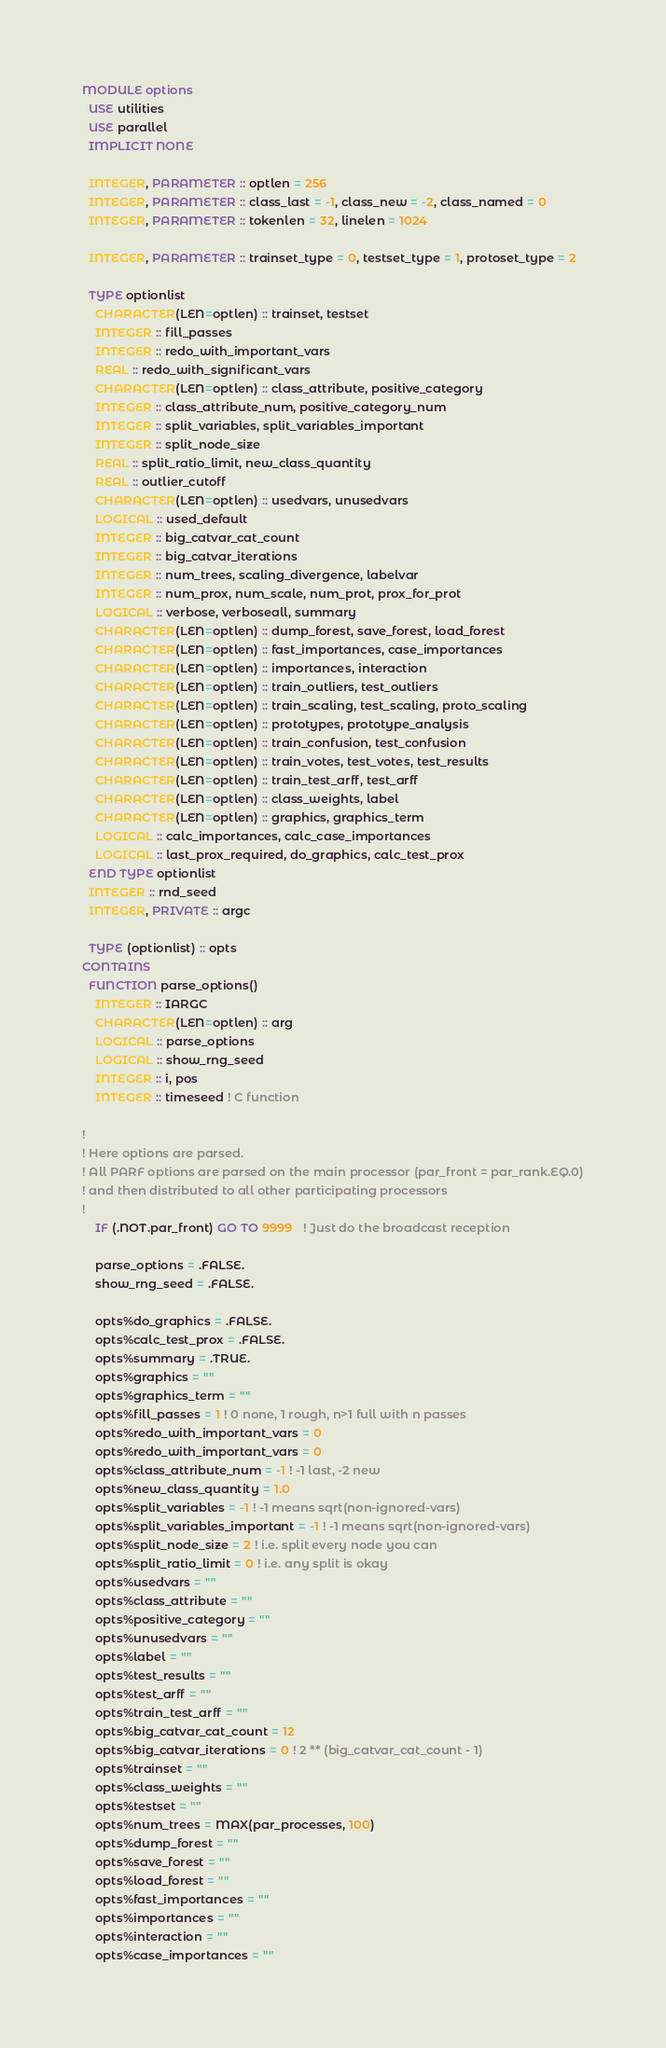<code> <loc_0><loc_0><loc_500><loc_500><_FORTRAN_>MODULE options
  USE utilities
  USE parallel
  IMPLICIT NONE

  INTEGER, PARAMETER :: optlen = 256
  INTEGER, PARAMETER :: class_last = -1, class_new = -2, class_named = 0
  INTEGER, PARAMETER :: tokenlen = 32, linelen = 1024

  INTEGER, PARAMETER :: trainset_type = 0, testset_type = 1, protoset_type = 2

  TYPE optionlist
    CHARACTER(LEN=optlen) :: trainset, testset
    INTEGER :: fill_passes
    INTEGER :: redo_with_important_vars
    REAL :: redo_with_significant_vars
    CHARACTER(LEN=optlen) :: class_attribute, positive_category
    INTEGER :: class_attribute_num, positive_category_num
    INTEGER :: split_variables, split_variables_important
    INTEGER :: split_node_size
    REAL :: split_ratio_limit, new_class_quantity
    REAL :: outlier_cutoff
    CHARACTER(LEN=optlen) :: usedvars, unusedvars
    LOGICAL :: used_default
    INTEGER :: big_catvar_cat_count
    INTEGER :: big_catvar_iterations 
    INTEGER :: num_trees, scaling_divergence, labelvar
    INTEGER :: num_prox, num_scale, num_prot, prox_for_prot
    LOGICAL :: verbose, verboseall, summary
    CHARACTER(LEN=optlen) :: dump_forest, save_forest, load_forest
    CHARACTER(LEN=optlen) :: fast_importances, case_importances
    CHARACTER(LEN=optlen) :: importances, interaction
    CHARACTER(LEN=optlen) :: train_outliers, test_outliers
    CHARACTER(LEN=optlen) :: train_scaling, test_scaling, proto_scaling
    CHARACTER(LEN=optlen) :: prototypes, prototype_analysis
    CHARACTER(LEN=optlen) :: train_confusion, test_confusion
    CHARACTER(LEN=optlen) :: train_votes, test_votes, test_results
    CHARACTER(LEN=optlen) :: train_test_arff, test_arff
    CHARACTER(LEN=optlen) :: class_weights, label
    CHARACTER(LEN=optlen) :: graphics, graphics_term
    LOGICAL :: calc_importances, calc_case_importances
    LOGICAL :: last_prox_required, do_graphics, calc_test_prox
  END TYPE optionlist
  INTEGER :: rnd_seed
  INTEGER, PRIVATE :: argc

  TYPE (optionlist) :: opts
CONTAINS
  FUNCTION parse_options()
    INTEGER :: IARGC
    CHARACTER(LEN=optlen) :: arg
    LOGICAL :: parse_options
    LOGICAL :: show_rng_seed
    INTEGER :: i, pos
    INTEGER :: timeseed ! C function

!
! Here options are parsed.
! All PARF options are parsed on the main processor (par_front = par_rank.EQ.0)
! and then distributed to all other participating processors
! 
    IF (.NOT.par_front) GO TO 9999   ! Just do the broadcast reception

    parse_options = .FALSE.
    show_rng_seed = .FALSE.

    opts%do_graphics = .FALSE.
    opts%calc_test_prox = .FALSE.
    opts%summary = .TRUE.
    opts%graphics = ""
    opts%graphics_term = ""
    opts%fill_passes = 1 ! 0 none, 1 rough, n>1 full with n passes
    opts%redo_with_important_vars = 0
    opts%redo_with_important_vars = 0
    opts%class_attribute_num = -1 ! -1 last, -2 new
    opts%new_class_quantity = 1.0
    opts%split_variables = -1 ! -1 means sqrt(non-ignored-vars)
    opts%split_variables_important = -1 ! -1 means sqrt(non-ignored-vars)
    opts%split_node_size = 2 ! i.e. split every node you can
    opts%split_ratio_limit = 0 ! i.e. any split is okay
    opts%usedvars = ""
    opts%class_attribute = ""
    opts%positive_category = ""
    opts%unusedvars = ""
    opts%label = ""
    opts%test_results = ""
    opts%test_arff = ""
    opts%train_test_arff = ""
    opts%big_catvar_cat_count = 12
    opts%big_catvar_iterations = 0 ! 2 ** (big_catvar_cat_count - 1)
    opts%trainset = ""
    opts%class_weights = ""
    opts%testset = ""
    opts%num_trees = MAX(par_processes, 100)
    opts%dump_forest = ""
    opts%save_forest = ""
    opts%load_forest = ""
    opts%fast_importances = ""
    opts%importances = ""
    opts%interaction = ""
    opts%case_importances = ""</code> 